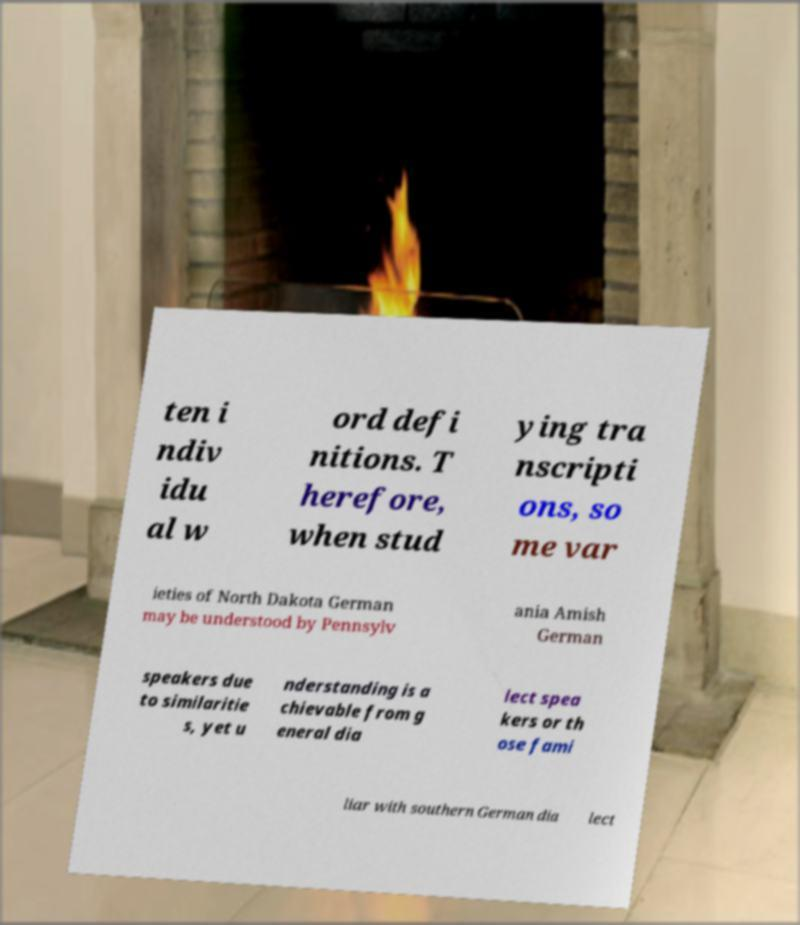Could you assist in decoding the text presented in this image and type it out clearly? ten i ndiv idu al w ord defi nitions. T herefore, when stud ying tra nscripti ons, so me var ieties of North Dakota German may be understood by Pennsylv ania Amish German speakers due to similaritie s, yet u nderstanding is a chievable from g eneral dia lect spea kers or th ose fami liar with southern German dia lect 